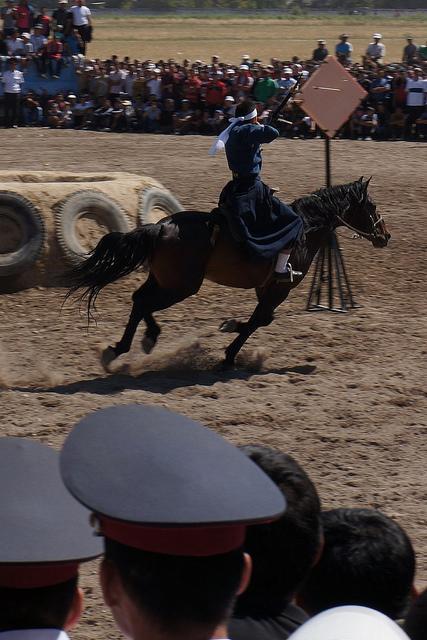How many people are there?
Give a very brief answer. 4. 